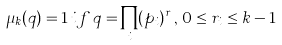Convert formula to latex. <formula><loc_0><loc_0><loc_500><loc_500>\mu _ { k } ( q ) = 1 \, i f \, q = \prod _ { i } ( p _ { i } ) ^ { r _ { i } } , \, 0 \leq r _ { i } \leq k - 1</formula> 